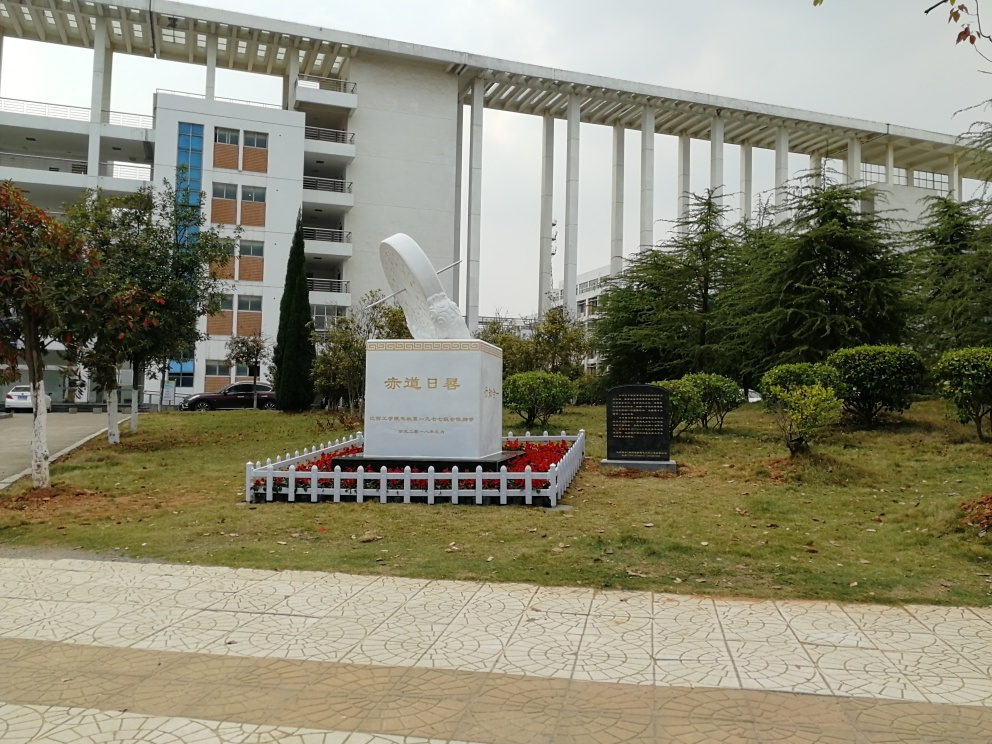What might be the purpose of the open structure extending from the building? The open structure extending from the building gives the impression of a modern design element, possibly functioning as an aesthetic feature or providing practical use such as shade or shelter for an outdoor area. Its prominent columns and the absence of walls suggest a design focus on openness and integration with the surrounding space. 